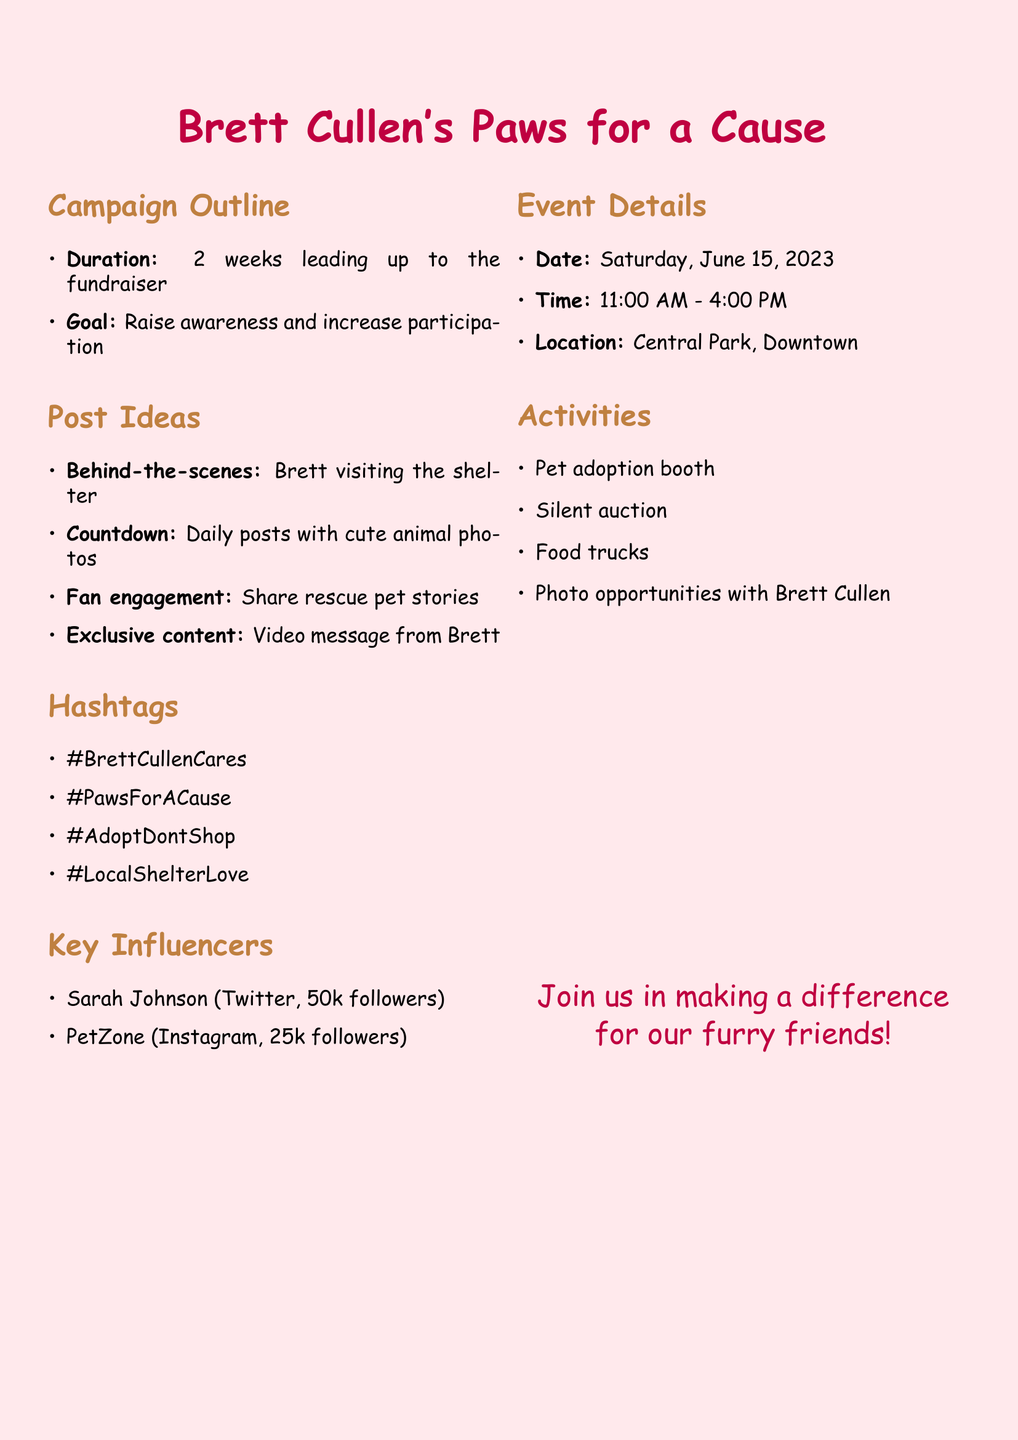what is the title of the campaign? The title of the campaign is provided in the title section of the document.
Answer: Brett Cullen's Paws for a Cause how long is the campaign duration? The duration is mentioned clearly in a bullet point format in the campaign outline.
Answer: 2 weeks what date is the fundraiser event scheduled? The date of the event is specified in the event details section.
Answer: Saturday, June 15, 2023 what type of posts are included in the post ideas? The types of posts are listed in the post ideas section of the document.
Answer: Behind-the-scenes, Countdown, Fan engagement, Exclusive content how many followers does Sarah Johnson have? The number of followers for Sarah Johnson is included in the key influencers section.
Answer: 50000 what activity involves Brett Cullen at the event? The activities are clearly listed in the activities section of the document.
Answer: Photo opportunities with Brett Cullen what is one of the hashtags used in the campaign? The hashtags are listed under the hashtags section, providing specific examples of what will be used in the campaign.
Answer: #BrettCullenCares what time does the event start? The starting time of the event is indicated in the event details section.
Answer: 11:00 AM who is a key influencer on Twitter? The key influencers are mentioned in the key influencers section, listing their names and platforms.
Answer: Sarah Johnson 